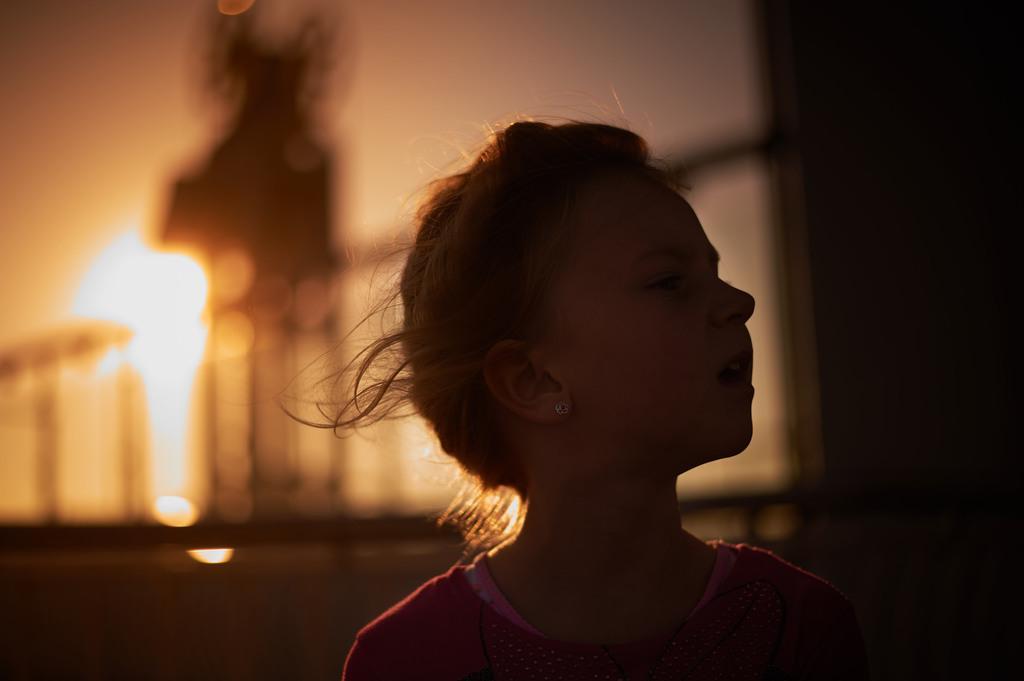In one or two sentences, can you explain what this image depicts? In the foreground of the image there is a girl. In the background of the image there is a railing. There is fire. At the top of the image there is sky. 